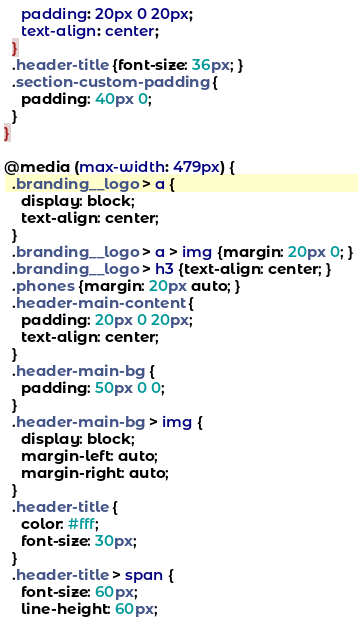<code> <loc_0><loc_0><loc_500><loc_500><_CSS_>    padding: 20px 0 20px;
    text-align: center;
  }
  .header-title {font-size: 36px; }
  .section-custom-padding {
    padding: 40px 0;
  }
}

@media (max-width: 479px) {
  .branding__logo > a {
    display: block;
    text-align: center;
  }
  .branding__logo > a > img {margin: 20px 0; }
  .branding__logo > h3 {text-align: center; }
  .phones {margin: 20px auto; }
  .header-main-content {
    padding: 20px 0 20px;
    text-align: center;
  }
  .header-main-bg {
    padding: 50px 0 0;
  }
  .header-main-bg > img {
    display: block;
    margin-left: auto;
    margin-right: auto;
  }
  .header-title {
    color: #fff;
    font-size: 30px;
  }
  .header-title > span {
    font-size: 60px;
    line-height: 60px;</code> 